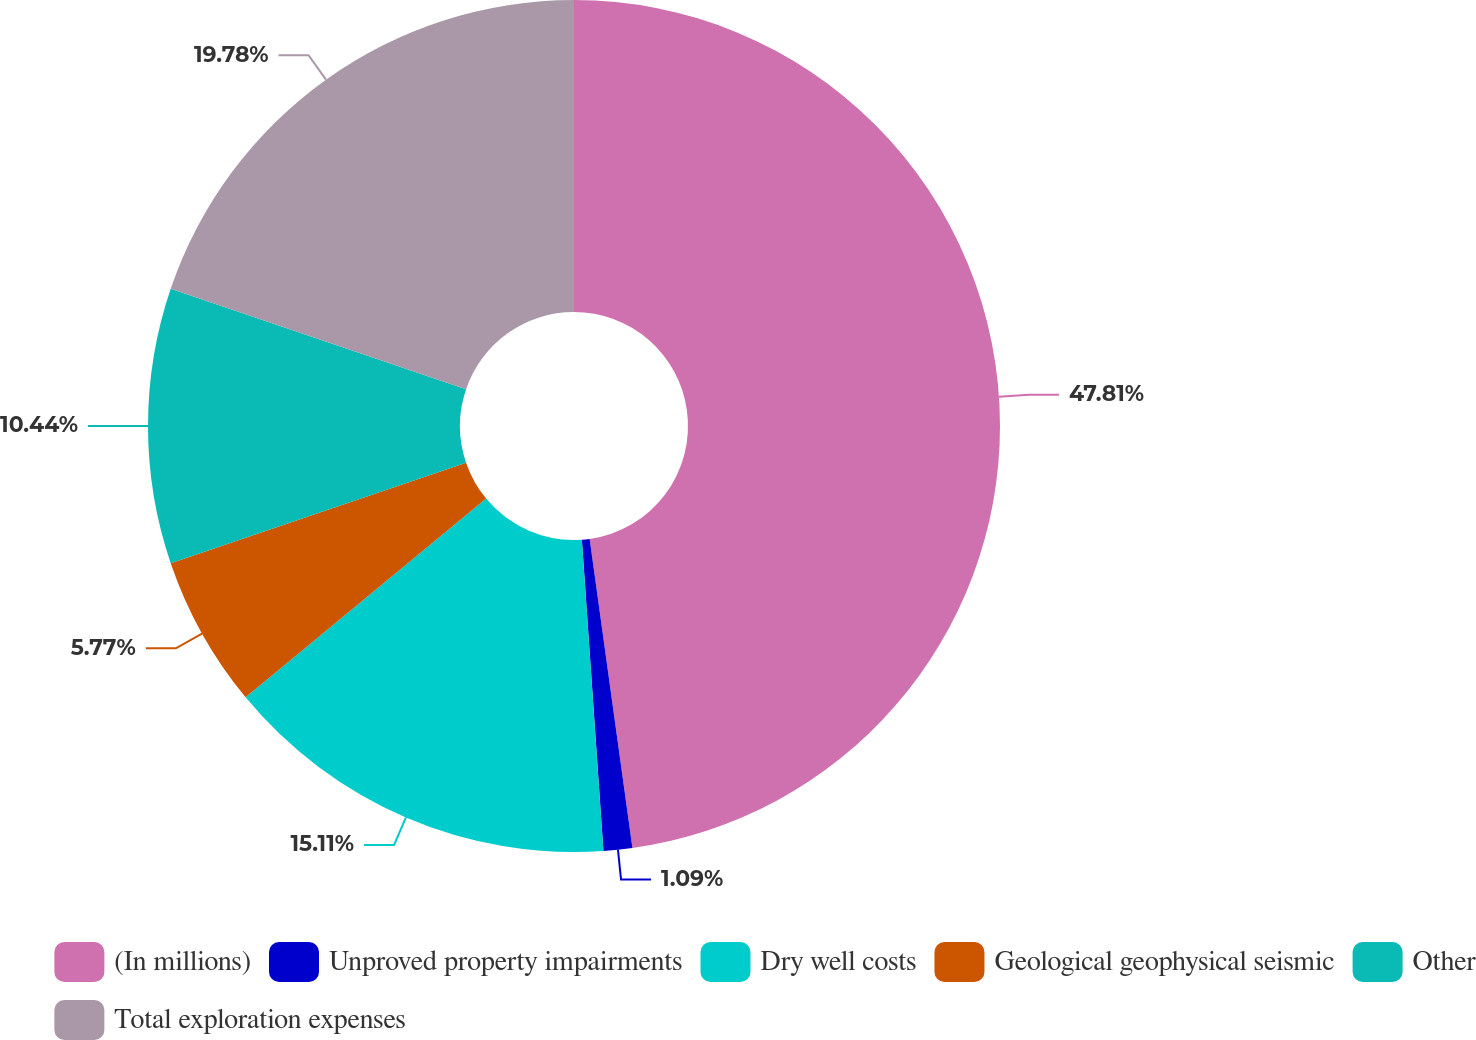Convert chart to OTSL. <chart><loc_0><loc_0><loc_500><loc_500><pie_chart><fcel>(In millions)<fcel>Unproved property impairments<fcel>Dry well costs<fcel>Geological geophysical seismic<fcel>Other<fcel>Total exploration expenses<nl><fcel>47.81%<fcel>1.09%<fcel>15.11%<fcel>5.77%<fcel>10.44%<fcel>19.78%<nl></chart> 